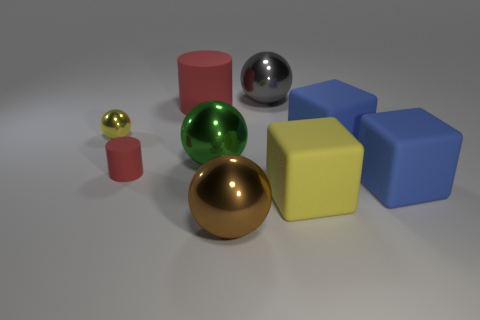Are there any objects that are similar in color but differ in material finish, and if so, which ones? Yes, the red cylinder and the red sphere share a similar color. However, they differ in material finish; the cylinder has a matte surface that scatters light, while the sphere has a glossy finish that reflects light clearly. 